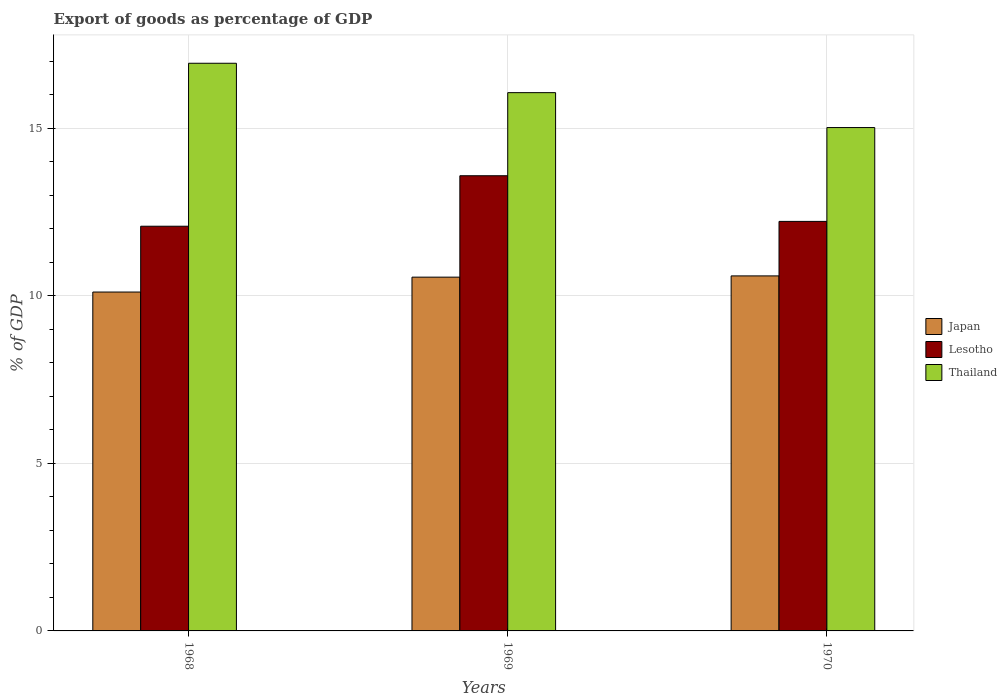How many different coloured bars are there?
Keep it short and to the point. 3. Are the number of bars per tick equal to the number of legend labels?
Give a very brief answer. Yes. How many bars are there on the 2nd tick from the right?
Your answer should be compact. 3. What is the label of the 1st group of bars from the left?
Make the answer very short. 1968. In how many cases, is the number of bars for a given year not equal to the number of legend labels?
Give a very brief answer. 0. What is the export of goods as percentage of GDP in Lesotho in 1968?
Your response must be concise. 12.08. Across all years, what is the maximum export of goods as percentage of GDP in Lesotho?
Offer a very short reply. 13.58. Across all years, what is the minimum export of goods as percentage of GDP in Lesotho?
Your answer should be very brief. 12.08. In which year was the export of goods as percentage of GDP in Lesotho maximum?
Keep it short and to the point. 1969. In which year was the export of goods as percentage of GDP in Lesotho minimum?
Your answer should be compact. 1968. What is the total export of goods as percentage of GDP in Japan in the graph?
Make the answer very short. 31.26. What is the difference between the export of goods as percentage of GDP in Thailand in 1969 and that in 1970?
Provide a succinct answer. 1.04. What is the difference between the export of goods as percentage of GDP in Lesotho in 1969 and the export of goods as percentage of GDP in Japan in 1970?
Give a very brief answer. 2.99. What is the average export of goods as percentage of GDP in Japan per year?
Provide a succinct answer. 10.42. In the year 1970, what is the difference between the export of goods as percentage of GDP in Japan and export of goods as percentage of GDP in Lesotho?
Provide a short and direct response. -1.63. In how many years, is the export of goods as percentage of GDP in Thailand greater than 16 %?
Offer a terse response. 2. What is the ratio of the export of goods as percentage of GDP in Japan in 1969 to that in 1970?
Provide a succinct answer. 1. Is the export of goods as percentage of GDP in Thailand in 1969 less than that in 1970?
Keep it short and to the point. No. Is the difference between the export of goods as percentage of GDP in Japan in 1969 and 1970 greater than the difference between the export of goods as percentage of GDP in Lesotho in 1969 and 1970?
Provide a short and direct response. No. What is the difference between the highest and the second highest export of goods as percentage of GDP in Thailand?
Offer a terse response. 0.88. What is the difference between the highest and the lowest export of goods as percentage of GDP in Japan?
Ensure brevity in your answer.  0.48. In how many years, is the export of goods as percentage of GDP in Japan greater than the average export of goods as percentage of GDP in Japan taken over all years?
Provide a short and direct response. 2. What does the 1st bar from the left in 1968 represents?
Your answer should be very brief. Japan. Is it the case that in every year, the sum of the export of goods as percentage of GDP in Lesotho and export of goods as percentage of GDP in Japan is greater than the export of goods as percentage of GDP in Thailand?
Make the answer very short. Yes. How many years are there in the graph?
Give a very brief answer. 3. What is the difference between two consecutive major ticks on the Y-axis?
Give a very brief answer. 5. Are the values on the major ticks of Y-axis written in scientific E-notation?
Your answer should be compact. No. Does the graph contain any zero values?
Give a very brief answer. No. How are the legend labels stacked?
Ensure brevity in your answer.  Vertical. What is the title of the graph?
Give a very brief answer. Export of goods as percentage of GDP. Does "Papua New Guinea" appear as one of the legend labels in the graph?
Offer a very short reply. No. What is the label or title of the X-axis?
Keep it short and to the point. Years. What is the label or title of the Y-axis?
Your answer should be very brief. % of GDP. What is the % of GDP in Japan in 1968?
Provide a succinct answer. 10.11. What is the % of GDP in Lesotho in 1968?
Keep it short and to the point. 12.08. What is the % of GDP of Thailand in 1968?
Your answer should be very brief. 16.94. What is the % of GDP of Japan in 1969?
Keep it short and to the point. 10.56. What is the % of GDP of Lesotho in 1969?
Offer a terse response. 13.58. What is the % of GDP in Thailand in 1969?
Keep it short and to the point. 16.06. What is the % of GDP in Japan in 1970?
Provide a succinct answer. 10.59. What is the % of GDP in Lesotho in 1970?
Offer a terse response. 12.22. What is the % of GDP of Thailand in 1970?
Keep it short and to the point. 15.02. Across all years, what is the maximum % of GDP of Japan?
Your answer should be very brief. 10.59. Across all years, what is the maximum % of GDP of Lesotho?
Provide a succinct answer. 13.58. Across all years, what is the maximum % of GDP in Thailand?
Ensure brevity in your answer.  16.94. Across all years, what is the minimum % of GDP in Japan?
Provide a short and direct response. 10.11. Across all years, what is the minimum % of GDP in Lesotho?
Give a very brief answer. 12.08. Across all years, what is the minimum % of GDP of Thailand?
Keep it short and to the point. 15.02. What is the total % of GDP of Japan in the graph?
Provide a short and direct response. 31.26. What is the total % of GDP in Lesotho in the graph?
Your answer should be very brief. 37.88. What is the total % of GDP of Thailand in the graph?
Make the answer very short. 48.02. What is the difference between the % of GDP of Japan in 1968 and that in 1969?
Your response must be concise. -0.44. What is the difference between the % of GDP in Lesotho in 1968 and that in 1969?
Ensure brevity in your answer.  -1.51. What is the difference between the % of GDP in Thailand in 1968 and that in 1969?
Offer a terse response. 0.88. What is the difference between the % of GDP in Japan in 1968 and that in 1970?
Make the answer very short. -0.48. What is the difference between the % of GDP of Lesotho in 1968 and that in 1970?
Keep it short and to the point. -0.14. What is the difference between the % of GDP in Thailand in 1968 and that in 1970?
Give a very brief answer. 1.92. What is the difference between the % of GDP of Japan in 1969 and that in 1970?
Offer a very short reply. -0.04. What is the difference between the % of GDP in Lesotho in 1969 and that in 1970?
Provide a succinct answer. 1.36. What is the difference between the % of GDP in Thailand in 1969 and that in 1970?
Offer a very short reply. 1.04. What is the difference between the % of GDP in Japan in 1968 and the % of GDP in Lesotho in 1969?
Your answer should be very brief. -3.47. What is the difference between the % of GDP of Japan in 1968 and the % of GDP of Thailand in 1969?
Offer a very short reply. -5.95. What is the difference between the % of GDP of Lesotho in 1968 and the % of GDP of Thailand in 1969?
Give a very brief answer. -3.99. What is the difference between the % of GDP in Japan in 1968 and the % of GDP in Lesotho in 1970?
Your answer should be very brief. -2.11. What is the difference between the % of GDP of Japan in 1968 and the % of GDP of Thailand in 1970?
Give a very brief answer. -4.91. What is the difference between the % of GDP in Lesotho in 1968 and the % of GDP in Thailand in 1970?
Provide a succinct answer. -2.94. What is the difference between the % of GDP in Japan in 1969 and the % of GDP in Lesotho in 1970?
Give a very brief answer. -1.66. What is the difference between the % of GDP in Japan in 1969 and the % of GDP in Thailand in 1970?
Your response must be concise. -4.46. What is the difference between the % of GDP of Lesotho in 1969 and the % of GDP of Thailand in 1970?
Offer a very short reply. -1.44. What is the average % of GDP of Japan per year?
Offer a terse response. 10.42. What is the average % of GDP of Lesotho per year?
Keep it short and to the point. 12.63. What is the average % of GDP in Thailand per year?
Offer a very short reply. 16.01. In the year 1968, what is the difference between the % of GDP of Japan and % of GDP of Lesotho?
Keep it short and to the point. -1.96. In the year 1968, what is the difference between the % of GDP of Japan and % of GDP of Thailand?
Provide a succinct answer. -6.83. In the year 1968, what is the difference between the % of GDP of Lesotho and % of GDP of Thailand?
Make the answer very short. -4.86. In the year 1969, what is the difference between the % of GDP in Japan and % of GDP in Lesotho?
Ensure brevity in your answer.  -3.03. In the year 1969, what is the difference between the % of GDP of Japan and % of GDP of Thailand?
Provide a succinct answer. -5.51. In the year 1969, what is the difference between the % of GDP of Lesotho and % of GDP of Thailand?
Your answer should be compact. -2.48. In the year 1970, what is the difference between the % of GDP of Japan and % of GDP of Lesotho?
Provide a succinct answer. -1.63. In the year 1970, what is the difference between the % of GDP in Japan and % of GDP in Thailand?
Your response must be concise. -4.43. In the year 1970, what is the difference between the % of GDP in Lesotho and % of GDP in Thailand?
Your answer should be very brief. -2.8. What is the ratio of the % of GDP of Japan in 1968 to that in 1969?
Your response must be concise. 0.96. What is the ratio of the % of GDP in Lesotho in 1968 to that in 1969?
Your response must be concise. 0.89. What is the ratio of the % of GDP in Thailand in 1968 to that in 1969?
Give a very brief answer. 1.05. What is the ratio of the % of GDP of Japan in 1968 to that in 1970?
Ensure brevity in your answer.  0.95. What is the ratio of the % of GDP of Thailand in 1968 to that in 1970?
Your answer should be very brief. 1.13. What is the ratio of the % of GDP of Japan in 1969 to that in 1970?
Give a very brief answer. 1. What is the ratio of the % of GDP of Lesotho in 1969 to that in 1970?
Keep it short and to the point. 1.11. What is the ratio of the % of GDP of Thailand in 1969 to that in 1970?
Offer a terse response. 1.07. What is the difference between the highest and the second highest % of GDP in Japan?
Provide a short and direct response. 0.04. What is the difference between the highest and the second highest % of GDP in Lesotho?
Your answer should be very brief. 1.36. What is the difference between the highest and the second highest % of GDP of Thailand?
Give a very brief answer. 0.88. What is the difference between the highest and the lowest % of GDP in Japan?
Offer a very short reply. 0.48. What is the difference between the highest and the lowest % of GDP in Lesotho?
Provide a succinct answer. 1.51. What is the difference between the highest and the lowest % of GDP of Thailand?
Your answer should be very brief. 1.92. 